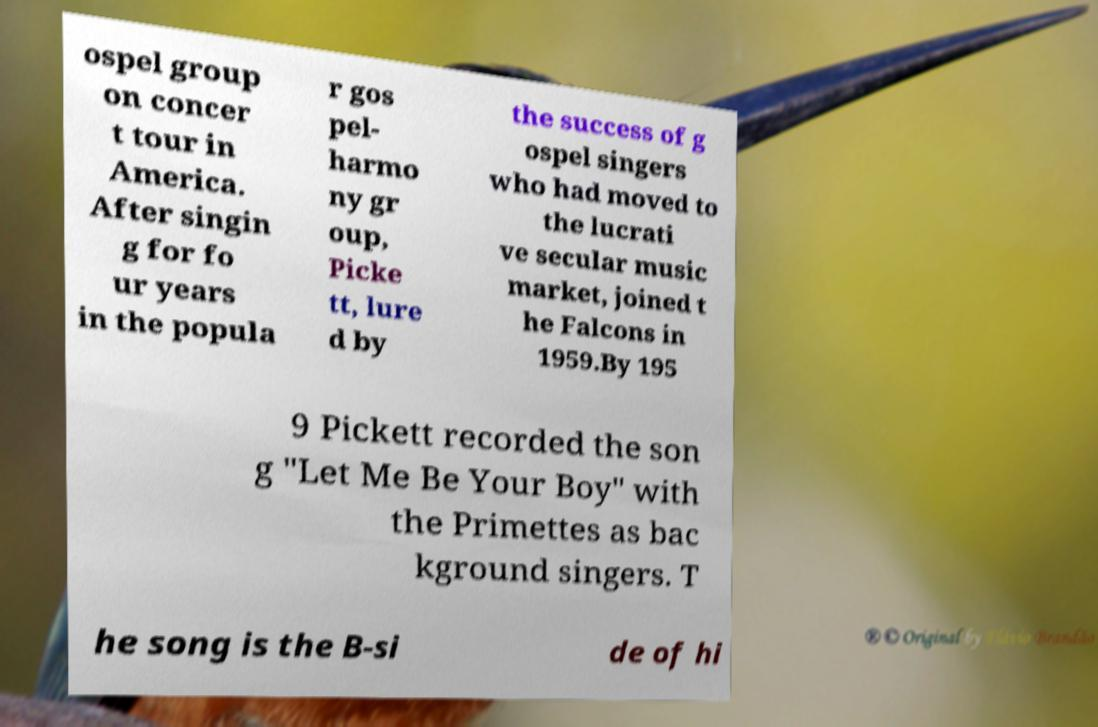Can you accurately transcribe the text from the provided image for me? ospel group on concer t tour in America. After singin g for fo ur years in the popula r gos pel- harmo ny gr oup, Picke tt, lure d by the success of g ospel singers who had moved to the lucrati ve secular music market, joined t he Falcons in 1959.By 195 9 Pickett recorded the son g "Let Me Be Your Boy" with the Primettes as bac kground singers. T he song is the B-si de of hi 